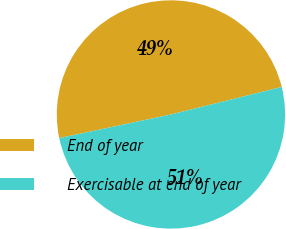Convert chart to OTSL. <chart><loc_0><loc_0><loc_500><loc_500><pie_chart><fcel>End of year<fcel>Exercisable at end of year<nl><fcel>49.45%<fcel>50.55%<nl></chart> 